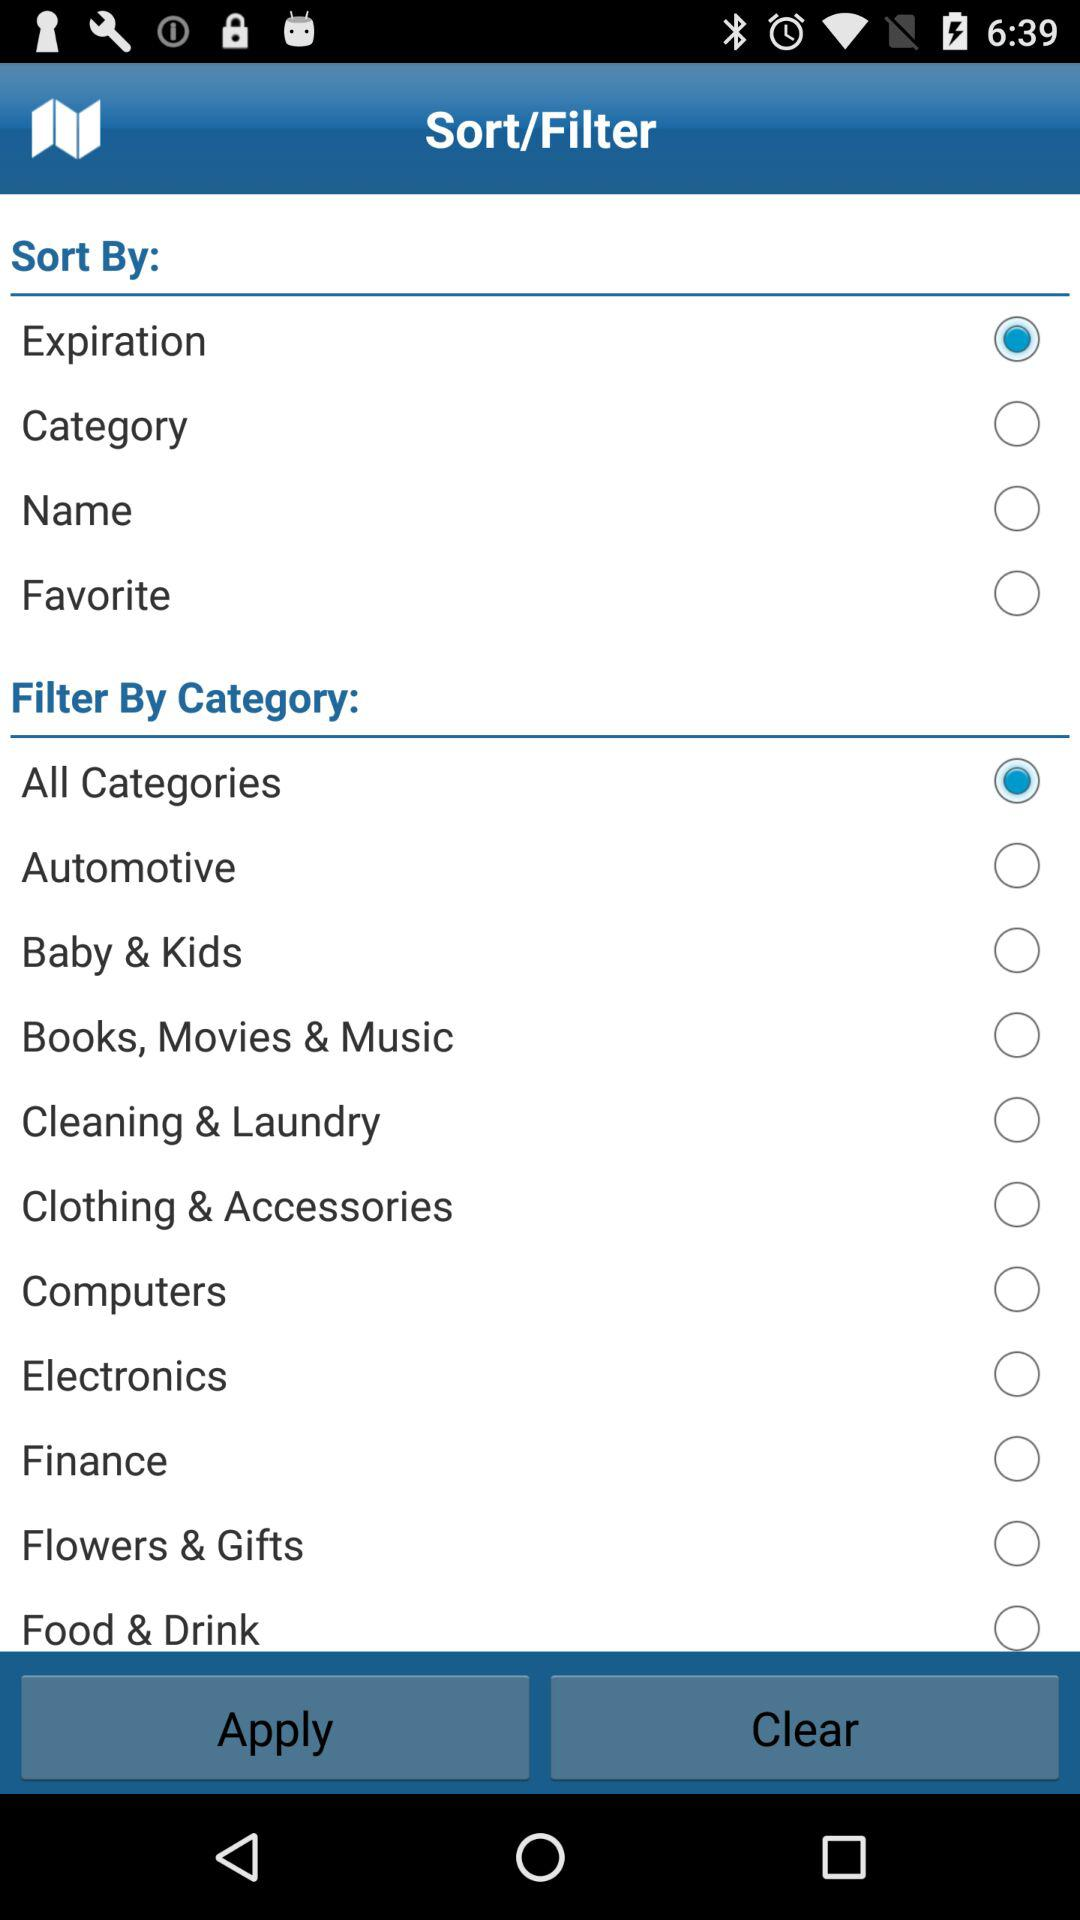What is the selected "Sort By" type? The selected "Sort By" type is Expiration. 